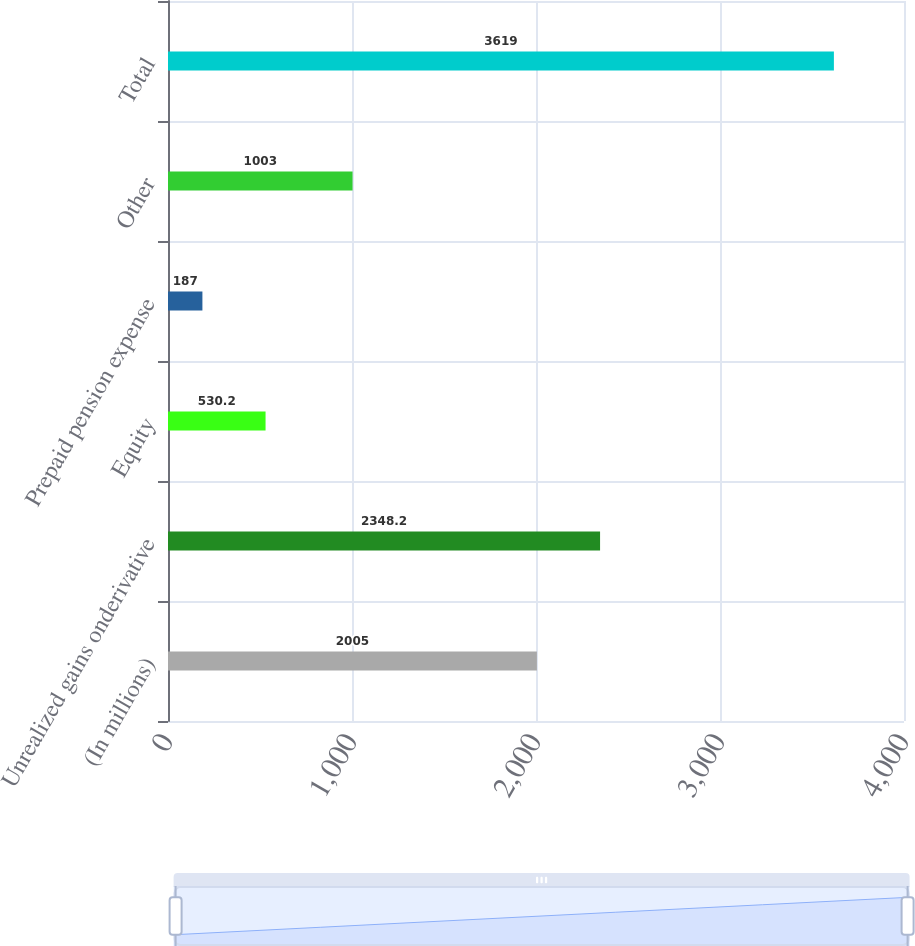Convert chart. <chart><loc_0><loc_0><loc_500><loc_500><bar_chart><fcel>(In millions)<fcel>Unrealized gains onderivative<fcel>Equity<fcel>Prepaid pension expense<fcel>Other<fcel>Total<nl><fcel>2005<fcel>2348.2<fcel>530.2<fcel>187<fcel>1003<fcel>3619<nl></chart> 